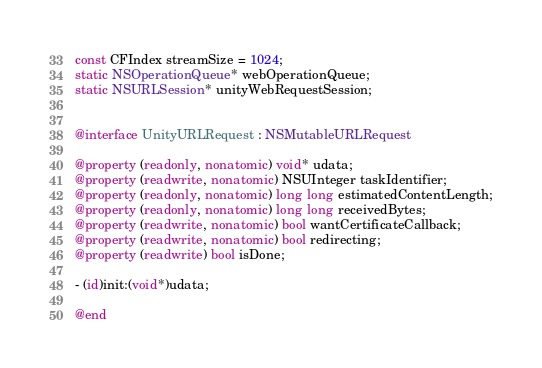<code> <loc_0><loc_0><loc_500><loc_500><_ObjectiveC_>const CFIndex streamSize = 1024;
static NSOperationQueue* webOperationQueue;
static NSURLSession* unityWebRequestSession;


@interface UnityURLRequest : NSMutableURLRequest

@property (readonly, nonatomic) void* udata;
@property (readwrite, nonatomic) NSUInteger taskIdentifier;
@property (readonly, nonatomic) long long estimatedContentLength;
@property (readonly, nonatomic) long long receivedBytes;
@property (readwrite, nonatomic) bool wantCertificateCallback;
@property (readwrite, nonatomic) bool redirecting;
@property (readwrite) bool isDone;

- (id)init:(void*)udata;

@end
</code> 